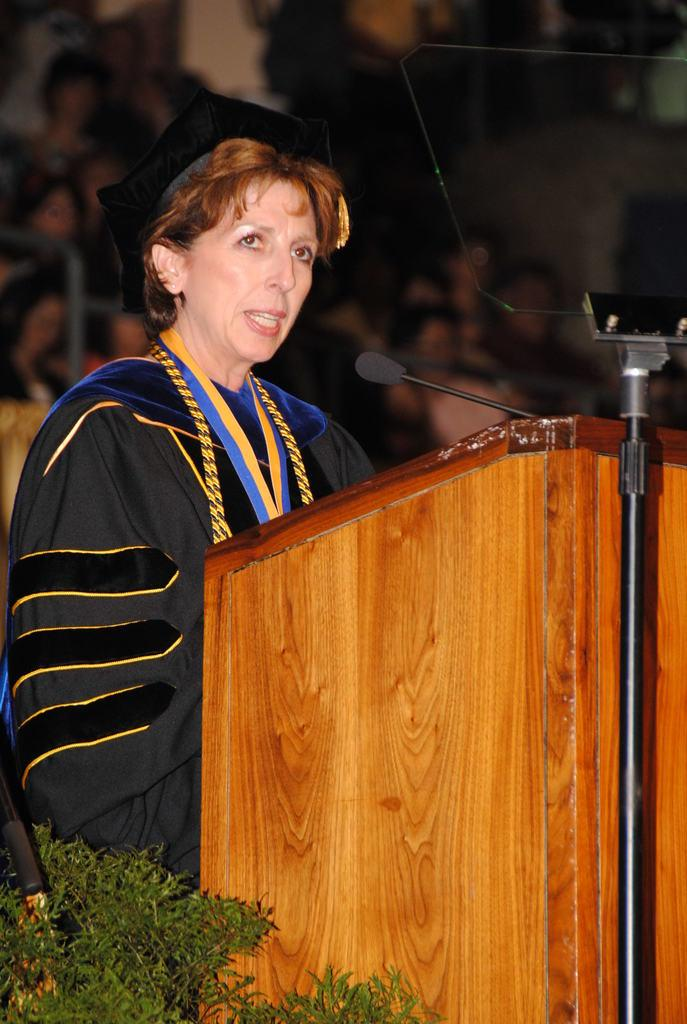Who is the main subject in the image? There is a woman in the image. What is the woman doing in the image? The woman is standing at a podium. What is the woman using to amplify her voice in the image? There is a microphone in front of the woman. What is the woman leaning on in the image? There is a stand in front of the woman. What type of vegetation is visible in the image? Leaves are visible in the image. What can be seen in the background of the image? There is a group of people in the background of the image. How would you describe the background in the image? The background is blurry. What type of money is the woman holding in the image? There is no money visible in the image. What type of discovery is the woman making at the podium in the image? There is no indication of a discovery being made in the image; the woman is simply standing at a podium with a microphone and a stand. 